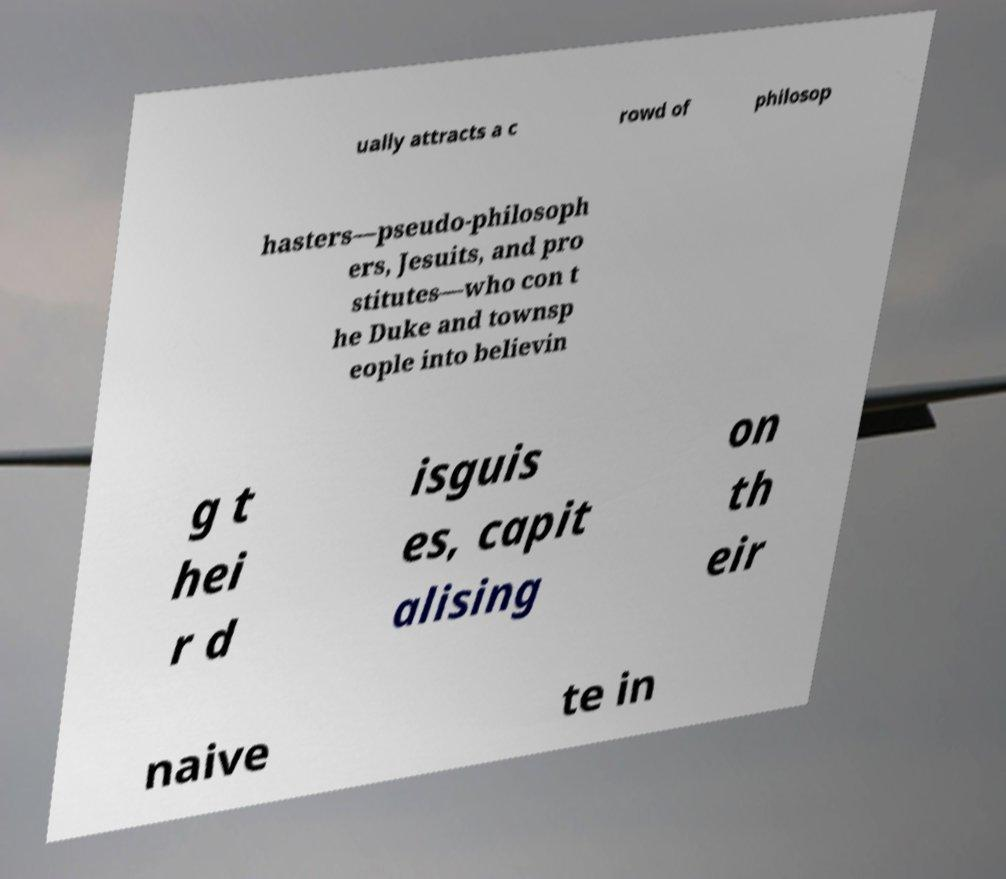I need the written content from this picture converted into text. Can you do that? ually attracts a c rowd of philosop hasters—pseudo-philosoph ers, Jesuits, and pro stitutes—who con t he Duke and townsp eople into believin g t hei r d isguis es, capit alising on th eir naive te in 